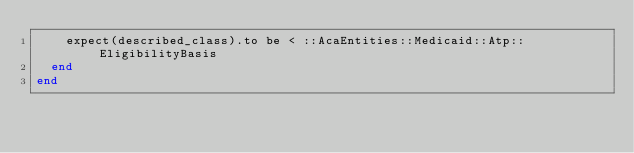Convert code to text. <code><loc_0><loc_0><loc_500><loc_500><_Ruby_>    expect(described_class).to be < ::AcaEntities::Medicaid::Atp::EligibilityBasis
  end
end
</code> 